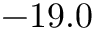<formula> <loc_0><loc_0><loc_500><loc_500>- 1 9 . 0</formula> 